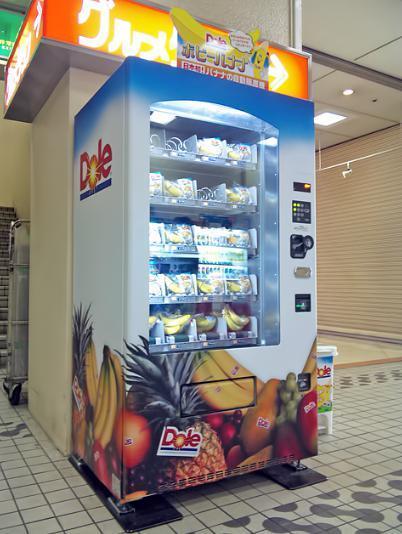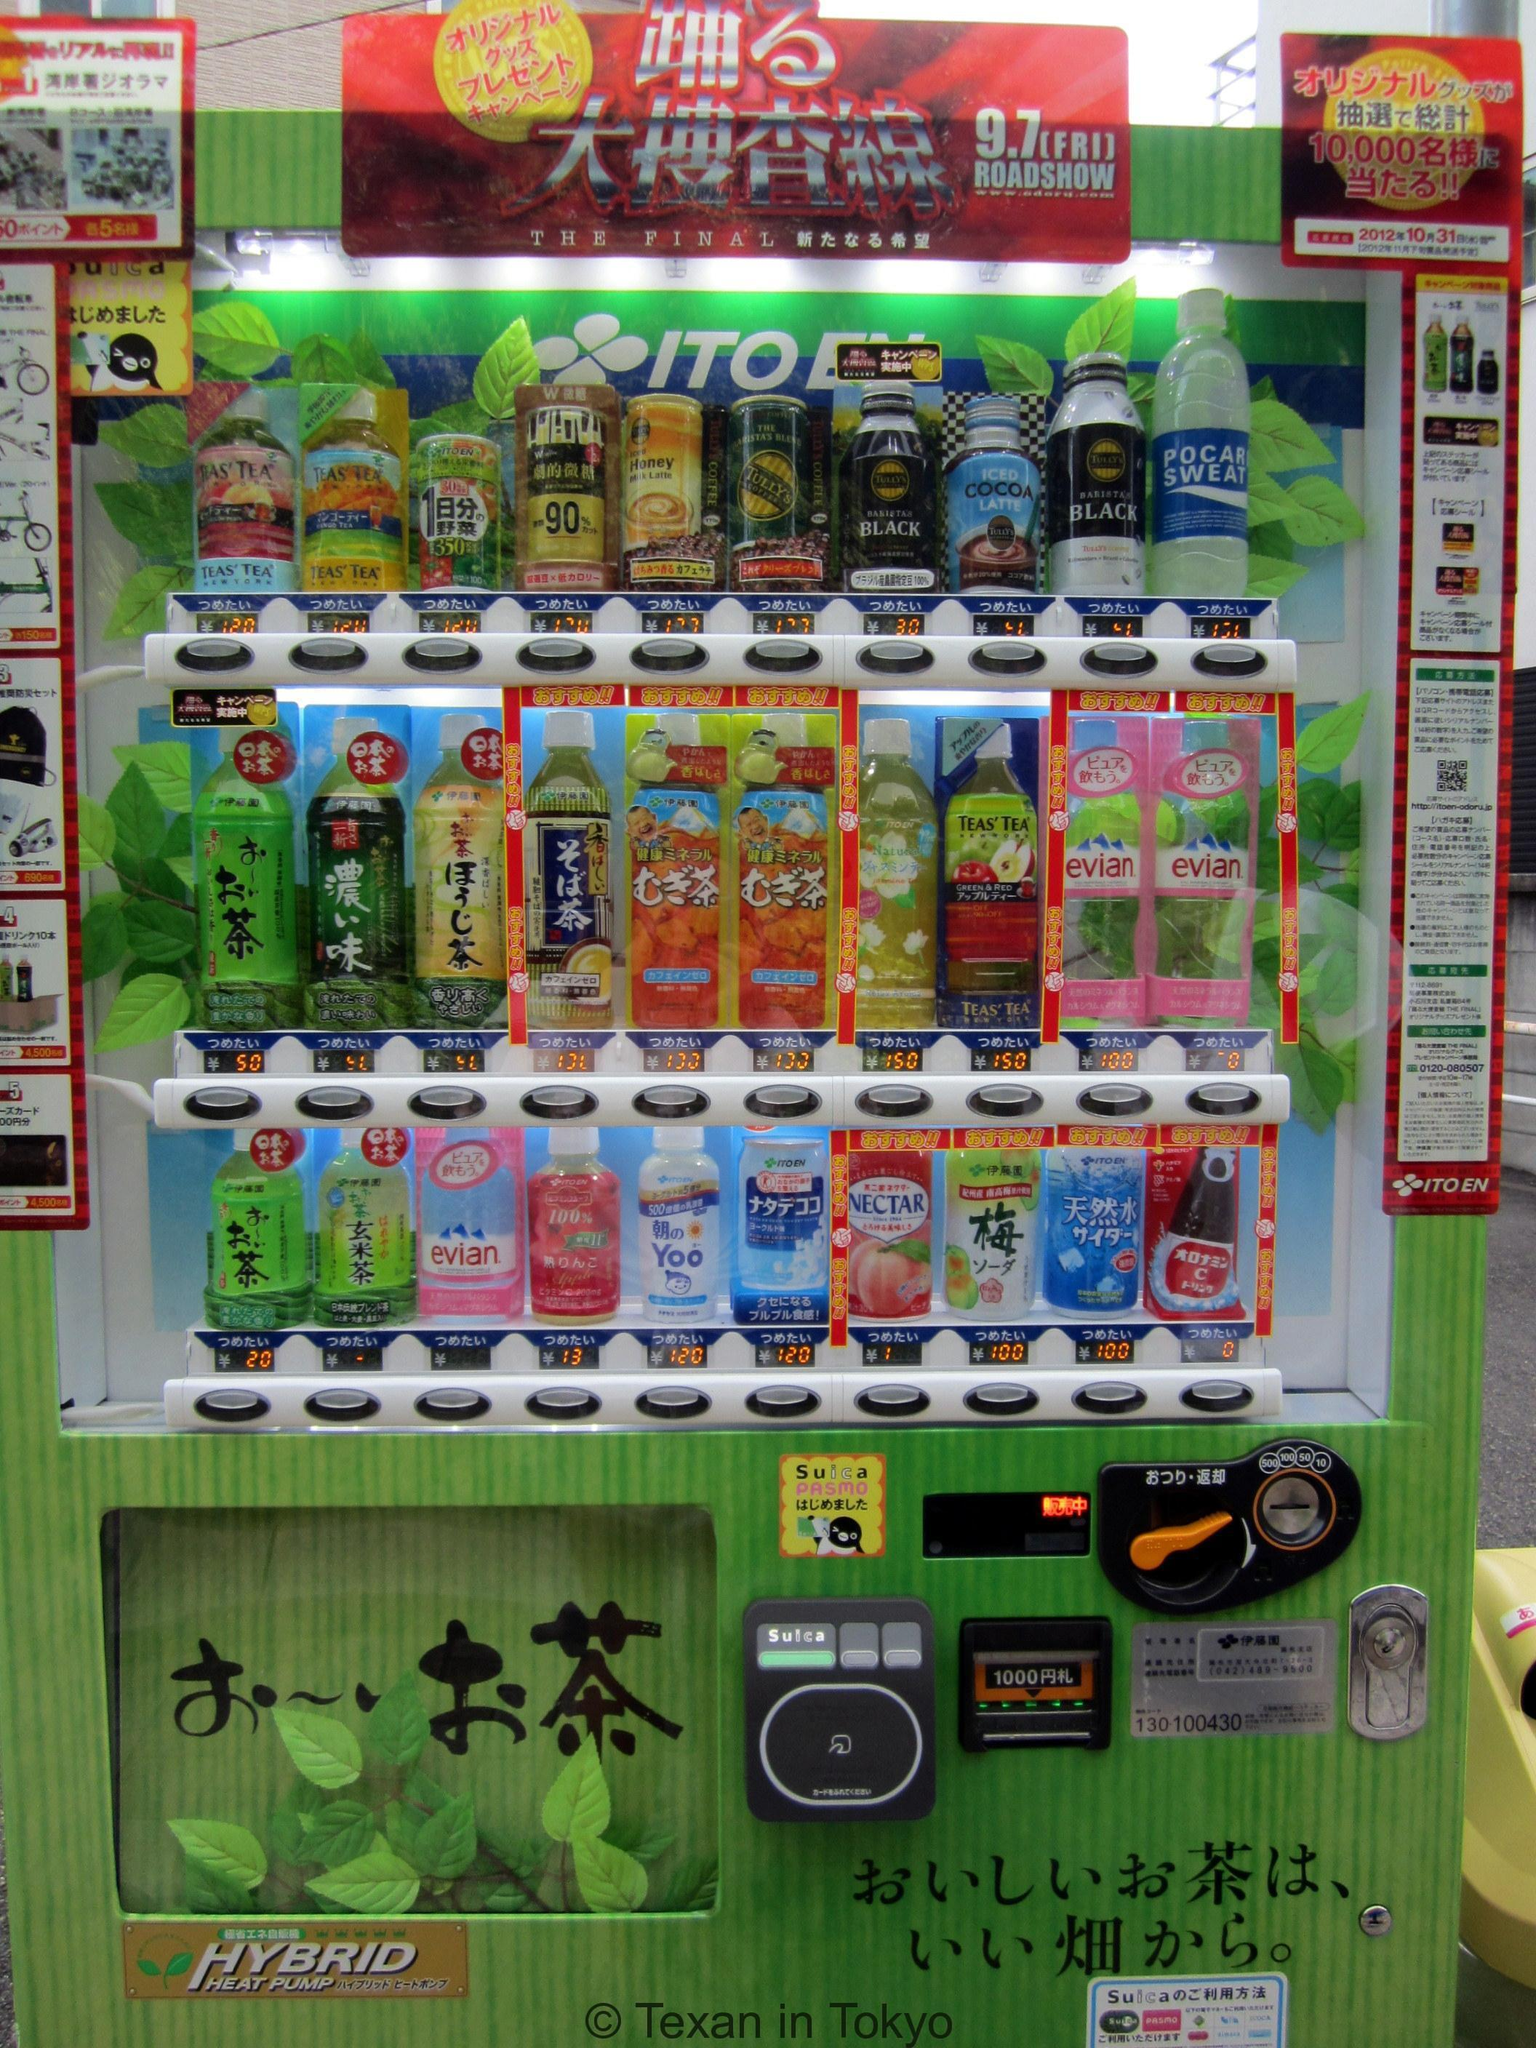The first image is the image on the left, the second image is the image on the right. Evaluate the accuracy of this statement regarding the images: "There is exactly one vending machine in the image on the left.". Is it true? Answer yes or no. Yes. 